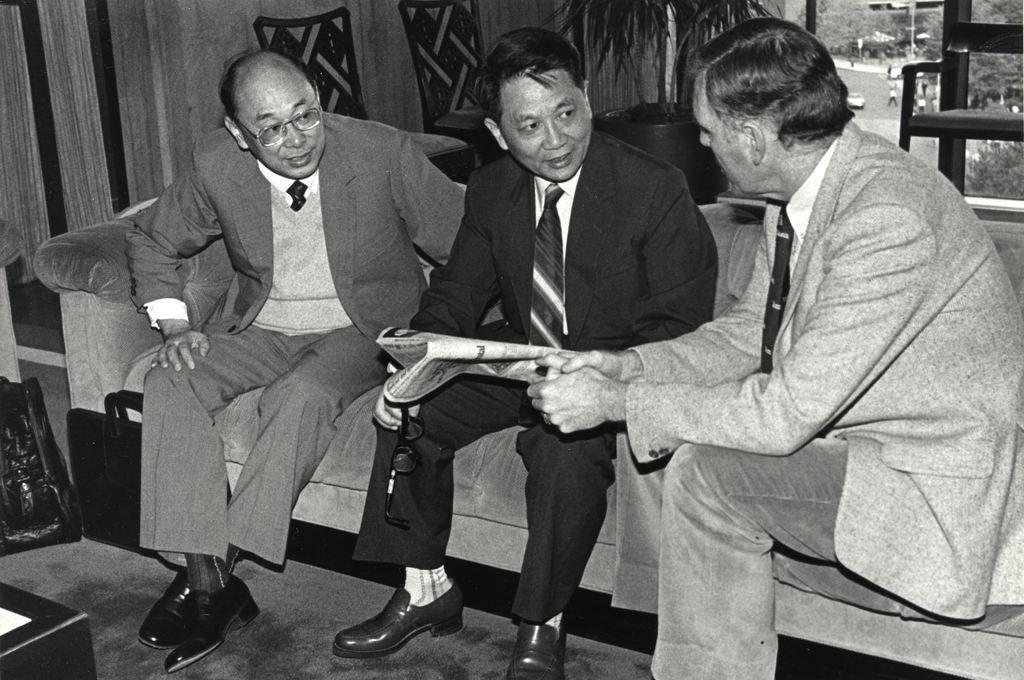Please provide a concise description of this image. In the picture i can see three persons wearing suits sitting on a couch and a person wearing black color suit holding newspaper in his hands and in the background of the picture there are some chairs, plant, window through which i can see road, some trees. 